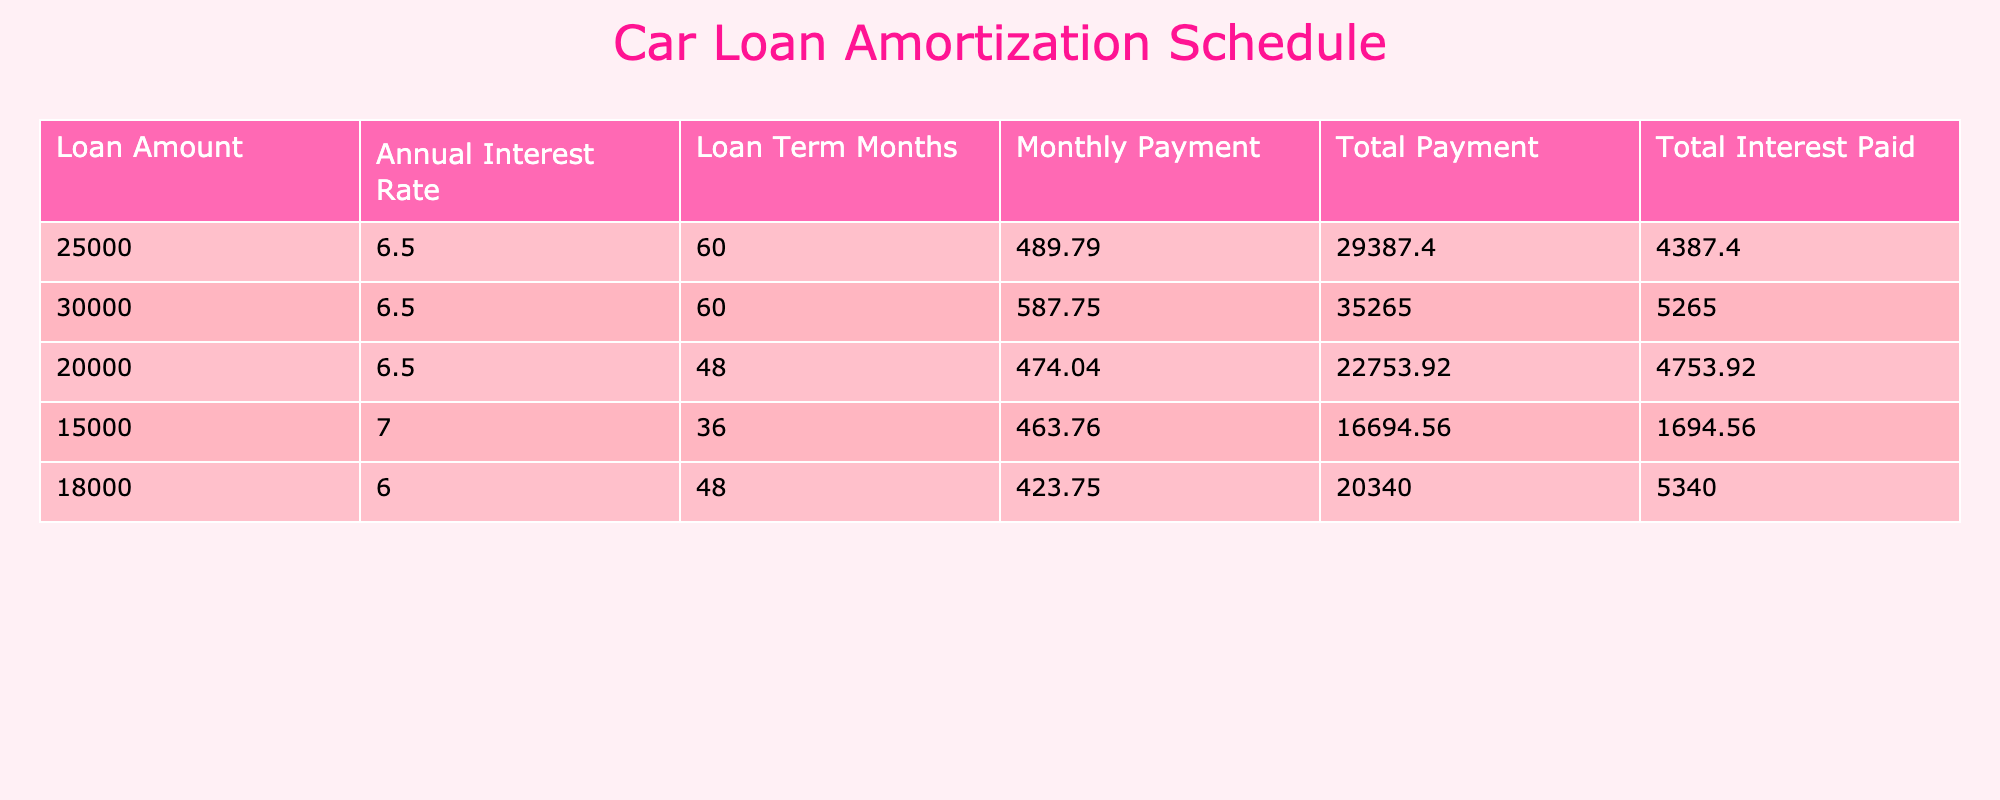What is the monthly payment for a loan amount of 30,000? From the table, I can directly observe the row corresponding to a loan amount of 30,000, which shows a monthly payment of 587.75.
Answer: 587.75 What is the total payment for the 20,000 loan? By looking at the row for the loan amount of 20,000, the total payment listed is 22,753.92.
Answer: 22,753.92 How much total interest is paid for a 15,000 loan at a 7.0% interest rate? The table displays the total interest paid for the 15,000 loan at a rate of 7.0% as 1,694.56.
Answer: 1,694.56 Is the total interest paid for a 25,000 loan less than 5,000? The total interest for the 25,000 loan is 4,387.40, which is indeed less than 5,000. Thus, the statement is true.
Answer: Yes What is the difference between total payments for the loans of 30,000 and 25,000? The total payment for the 30,000 loan is 35,265.00, while for the 25,000 loan, it is 29,387.40. To find the difference, I subtract: 35,265.00 - 29,387.40 = 5,877.60.
Answer: 5,877.60 Which loan amount has the highest monthly payment, and what is it? From the table, inspecting the monthly payments, the loan amount of 30,000 has the highest monthly payment of 587.75.
Answer: 30,000; 587.75 If I were to sum the total interest paid for the first three loans, what would it be? The total interest paid for the first three loans are: 4,387.40 (for 25,000) + 5,265.00 (for 30,000) + 4,753.92 (for 20,000). Adding them gives: 4,387.40 + 5,265.00 + 4,753.92 = 14,406.32.
Answer: 14,406.32 Which loan has the lowest total payment, and what is that amount? Looking through the total payments, the smallest amount is associated with the 15,000 loan, which totals to 16,694.56.
Answer: 15,000; 16,694.56 If I were to calculate the average monthly payment for all loans listed in the table, what would that be? To find the average, I sum up all monthly payments (489.79 + 587.75 + 474.04 + 463.76 + 423.75) = 2,438.09. Then, I divide this total by the number of loans (5): 2,438.09 / 5 = 487.62.
Answer: 487.62 